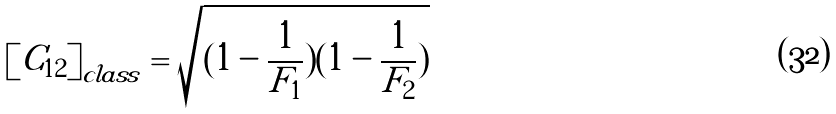Convert formula to latex. <formula><loc_0><loc_0><loc_500><loc_500>\left [ C _ { 1 2 } \right ] _ { c l a s s } = \sqrt { ( 1 - \frac { 1 } { F _ { 1 } } ) ( 1 - \frac { 1 } { F _ { 2 } } ) }</formula> 